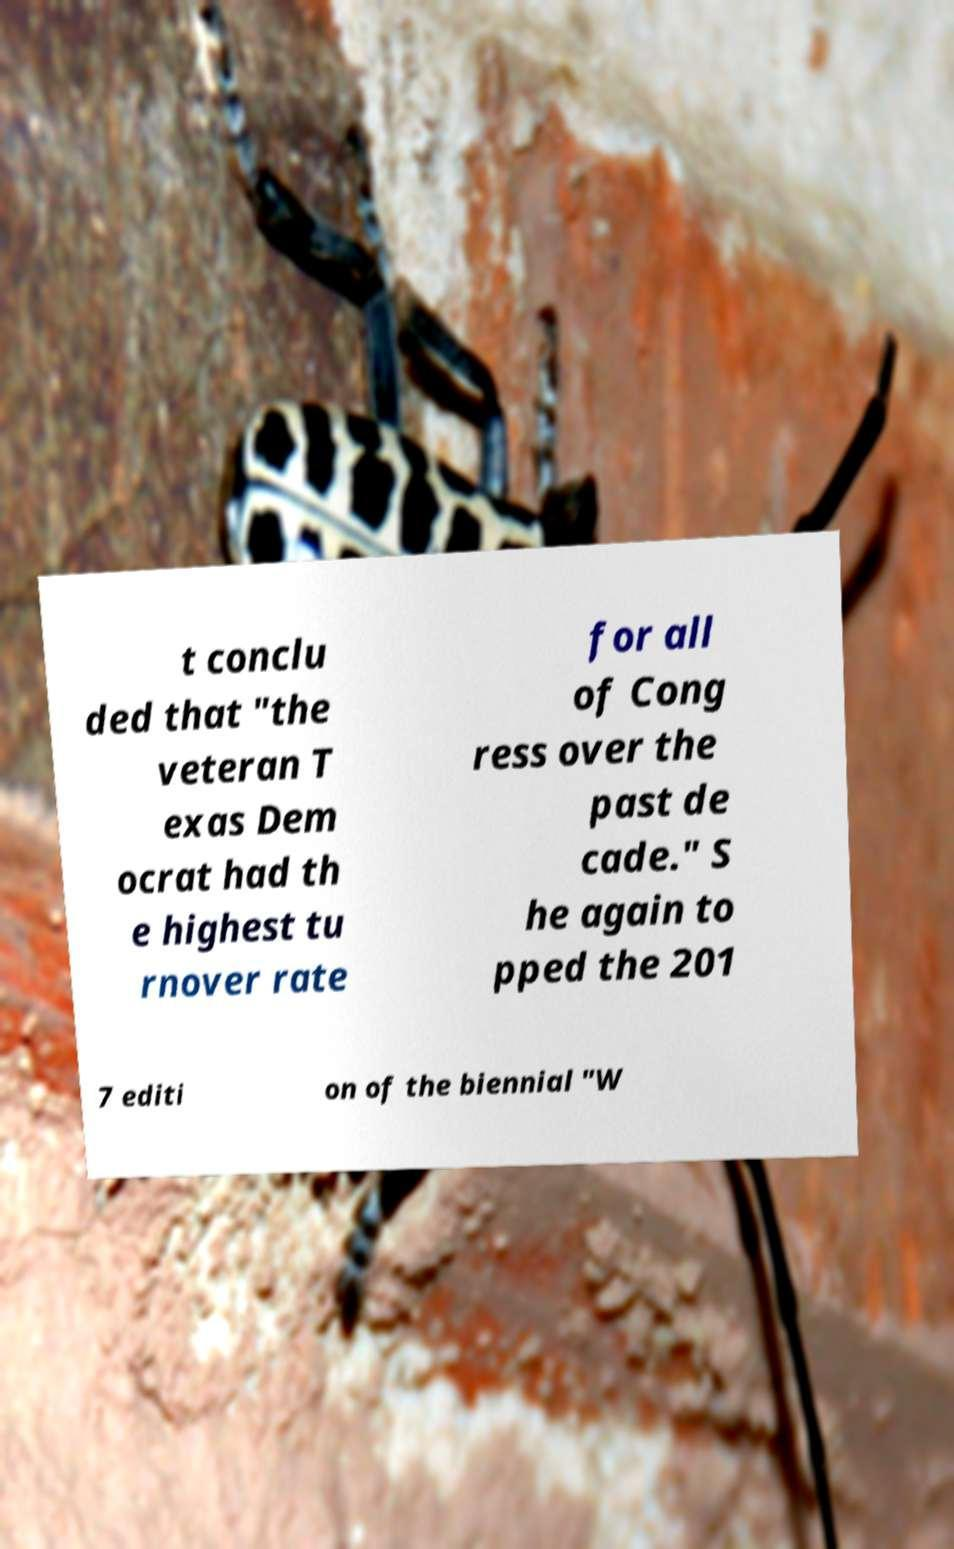For documentation purposes, I need the text within this image transcribed. Could you provide that? t conclu ded that "the veteran T exas Dem ocrat had th e highest tu rnover rate for all of Cong ress over the past de cade." S he again to pped the 201 7 editi on of the biennial "W 